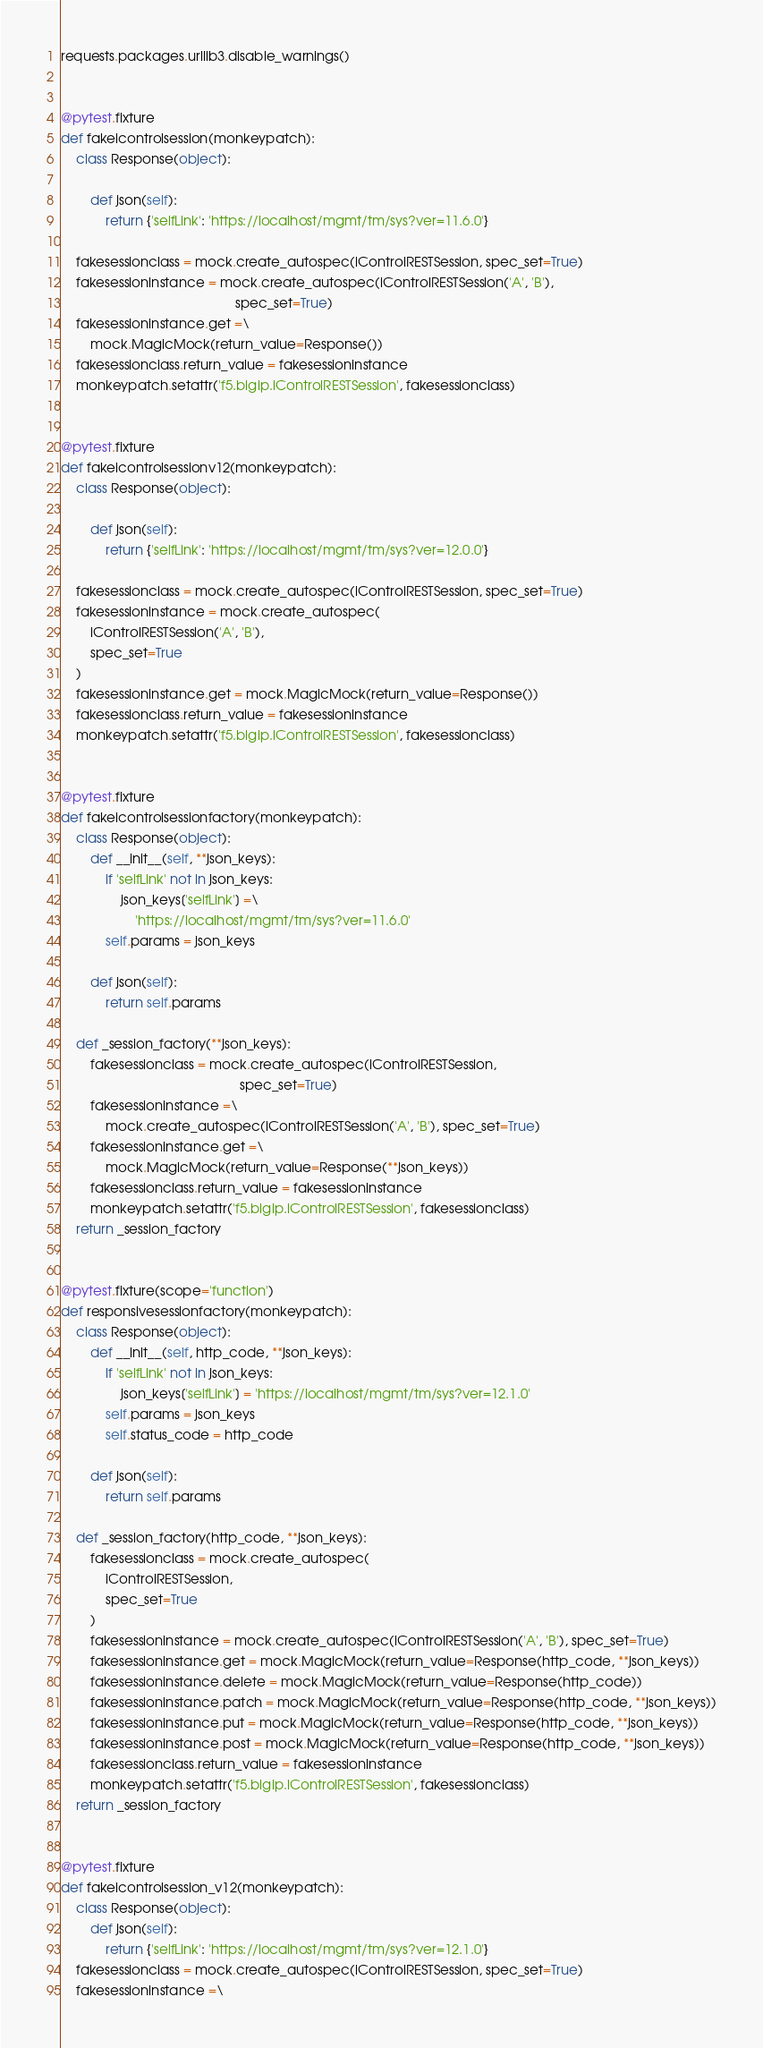Convert code to text. <code><loc_0><loc_0><loc_500><loc_500><_Python_>
requests.packages.urllib3.disable_warnings()


@pytest.fixture
def fakeicontrolsession(monkeypatch):
    class Response(object):

        def json(self):
            return {'selfLink': 'https://localhost/mgmt/tm/sys?ver=11.6.0'}

    fakesessionclass = mock.create_autospec(iControlRESTSession, spec_set=True)
    fakesessioninstance = mock.create_autospec(iControlRESTSession('A', 'B'),
                                               spec_set=True)
    fakesessioninstance.get =\
        mock.MagicMock(return_value=Response())
    fakesessionclass.return_value = fakesessioninstance
    monkeypatch.setattr('f5.bigip.iControlRESTSession', fakesessionclass)


@pytest.fixture
def fakeicontrolsessionv12(monkeypatch):
    class Response(object):

        def json(self):
            return {'selfLink': 'https://localhost/mgmt/tm/sys?ver=12.0.0'}

    fakesessionclass = mock.create_autospec(iControlRESTSession, spec_set=True)
    fakesessioninstance = mock.create_autospec(
        iControlRESTSession('A', 'B'),
        spec_set=True
    )
    fakesessioninstance.get = mock.MagicMock(return_value=Response())
    fakesessionclass.return_value = fakesessioninstance
    monkeypatch.setattr('f5.bigip.iControlRESTSession', fakesessionclass)


@pytest.fixture
def fakeicontrolsessionfactory(monkeypatch):
    class Response(object):
        def __init__(self, **json_keys):
            if 'selfLink' not in json_keys:
                json_keys['selfLink'] =\
                    'https://localhost/mgmt/tm/sys?ver=11.6.0'
            self.params = json_keys

        def json(self):
            return self.params

    def _session_factory(**json_keys):
        fakesessionclass = mock.create_autospec(iControlRESTSession,
                                                spec_set=True)
        fakesessioninstance =\
            mock.create_autospec(iControlRESTSession('A', 'B'), spec_set=True)
        fakesessioninstance.get =\
            mock.MagicMock(return_value=Response(**json_keys))
        fakesessionclass.return_value = fakesessioninstance
        monkeypatch.setattr('f5.bigip.iControlRESTSession', fakesessionclass)
    return _session_factory


@pytest.fixture(scope='function')
def responsivesessionfactory(monkeypatch):
    class Response(object):
        def __init__(self, http_code, **json_keys):
            if 'selfLink' not in json_keys:
                json_keys['selfLink'] = 'https://localhost/mgmt/tm/sys?ver=12.1.0'
            self.params = json_keys
            self.status_code = http_code

        def json(self):
            return self.params

    def _session_factory(http_code, **json_keys):
        fakesessionclass = mock.create_autospec(
            iControlRESTSession,
            spec_set=True
        )
        fakesessioninstance = mock.create_autospec(iControlRESTSession('A', 'B'), spec_set=True)
        fakesessioninstance.get = mock.MagicMock(return_value=Response(http_code, **json_keys))
        fakesessioninstance.delete = mock.MagicMock(return_value=Response(http_code))
        fakesessioninstance.patch = mock.MagicMock(return_value=Response(http_code, **json_keys))
        fakesessioninstance.put = mock.MagicMock(return_value=Response(http_code, **json_keys))
        fakesessioninstance.post = mock.MagicMock(return_value=Response(http_code, **json_keys))
        fakesessionclass.return_value = fakesessioninstance
        monkeypatch.setattr('f5.bigip.iControlRESTSession', fakesessionclass)
    return _session_factory


@pytest.fixture
def fakeicontrolsession_v12(monkeypatch):
    class Response(object):
        def json(self):
            return {'selfLink': 'https://localhost/mgmt/tm/sys?ver=12.1.0'}
    fakesessionclass = mock.create_autospec(iControlRESTSession, spec_set=True)
    fakesessioninstance =\</code> 